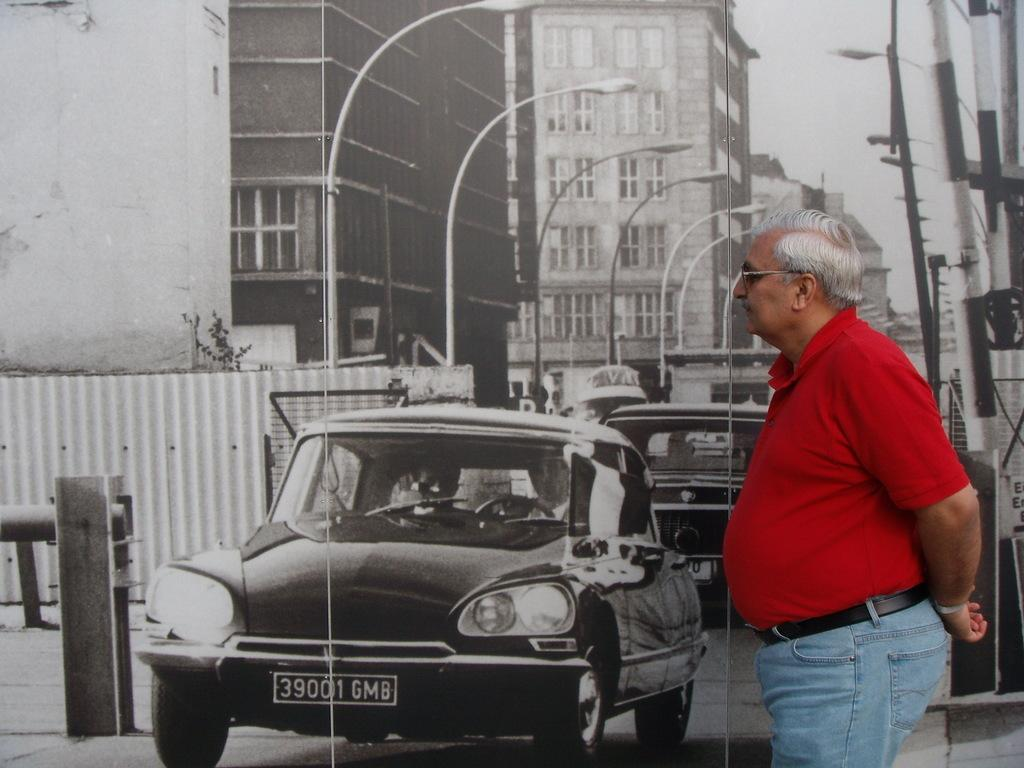Who is present on the right side of the image? There is a man on the right side of the image. What is the man looking at? The man is looking at a poster. What types of images are featured on the poster? The poster contains images of buildings, street lights, and vehicles. How many people are in the crowd depicted on the poster? There is no crowd depicted on the poster; it contains images of buildings, street lights, and vehicles. 